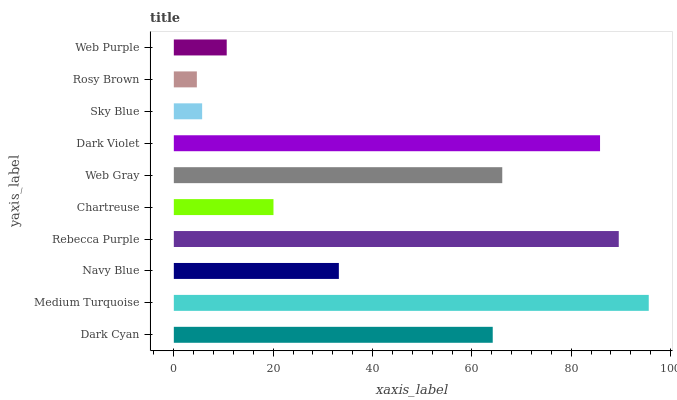Is Rosy Brown the minimum?
Answer yes or no. Yes. Is Medium Turquoise the maximum?
Answer yes or no. Yes. Is Navy Blue the minimum?
Answer yes or no. No. Is Navy Blue the maximum?
Answer yes or no. No. Is Medium Turquoise greater than Navy Blue?
Answer yes or no. Yes. Is Navy Blue less than Medium Turquoise?
Answer yes or no. Yes. Is Navy Blue greater than Medium Turquoise?
Answer yes or no. No. Is Medium Turquoise less than Navy Blue?
Answer yes or no. No. Is Dark Cyan the high median?
Answer yes or no. Yes. Is Navy Blue the low median?
Answer yes or no. Yes. Is Rebecca Purple the high median?
Answer yes or no. No. Is Rosy Brown the low median?
Answer yes or no. No. 